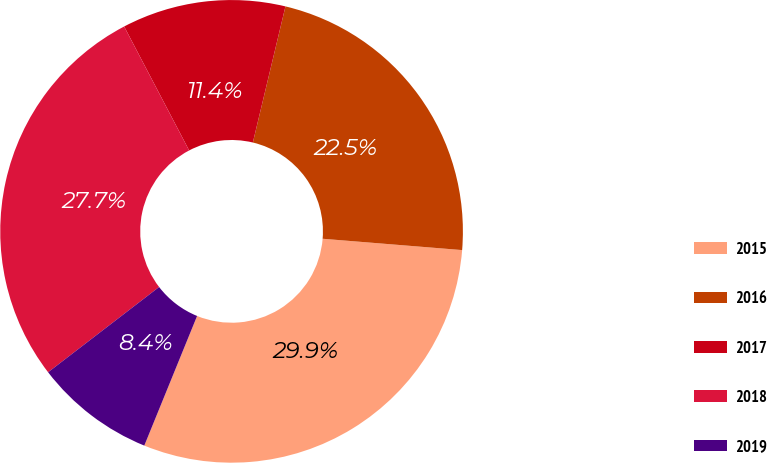<chart> <loc_0><loc_0><loc_500><loc_500><pie_chart><fcel>2015<fcel>2016<fcel>2017<fcel>2018<fcel>2019<nl><fcel>29.87%<fcel>22.55%<fcel>11.43%<fcel>27.74%<fcel>8.42%<nl></chart> 